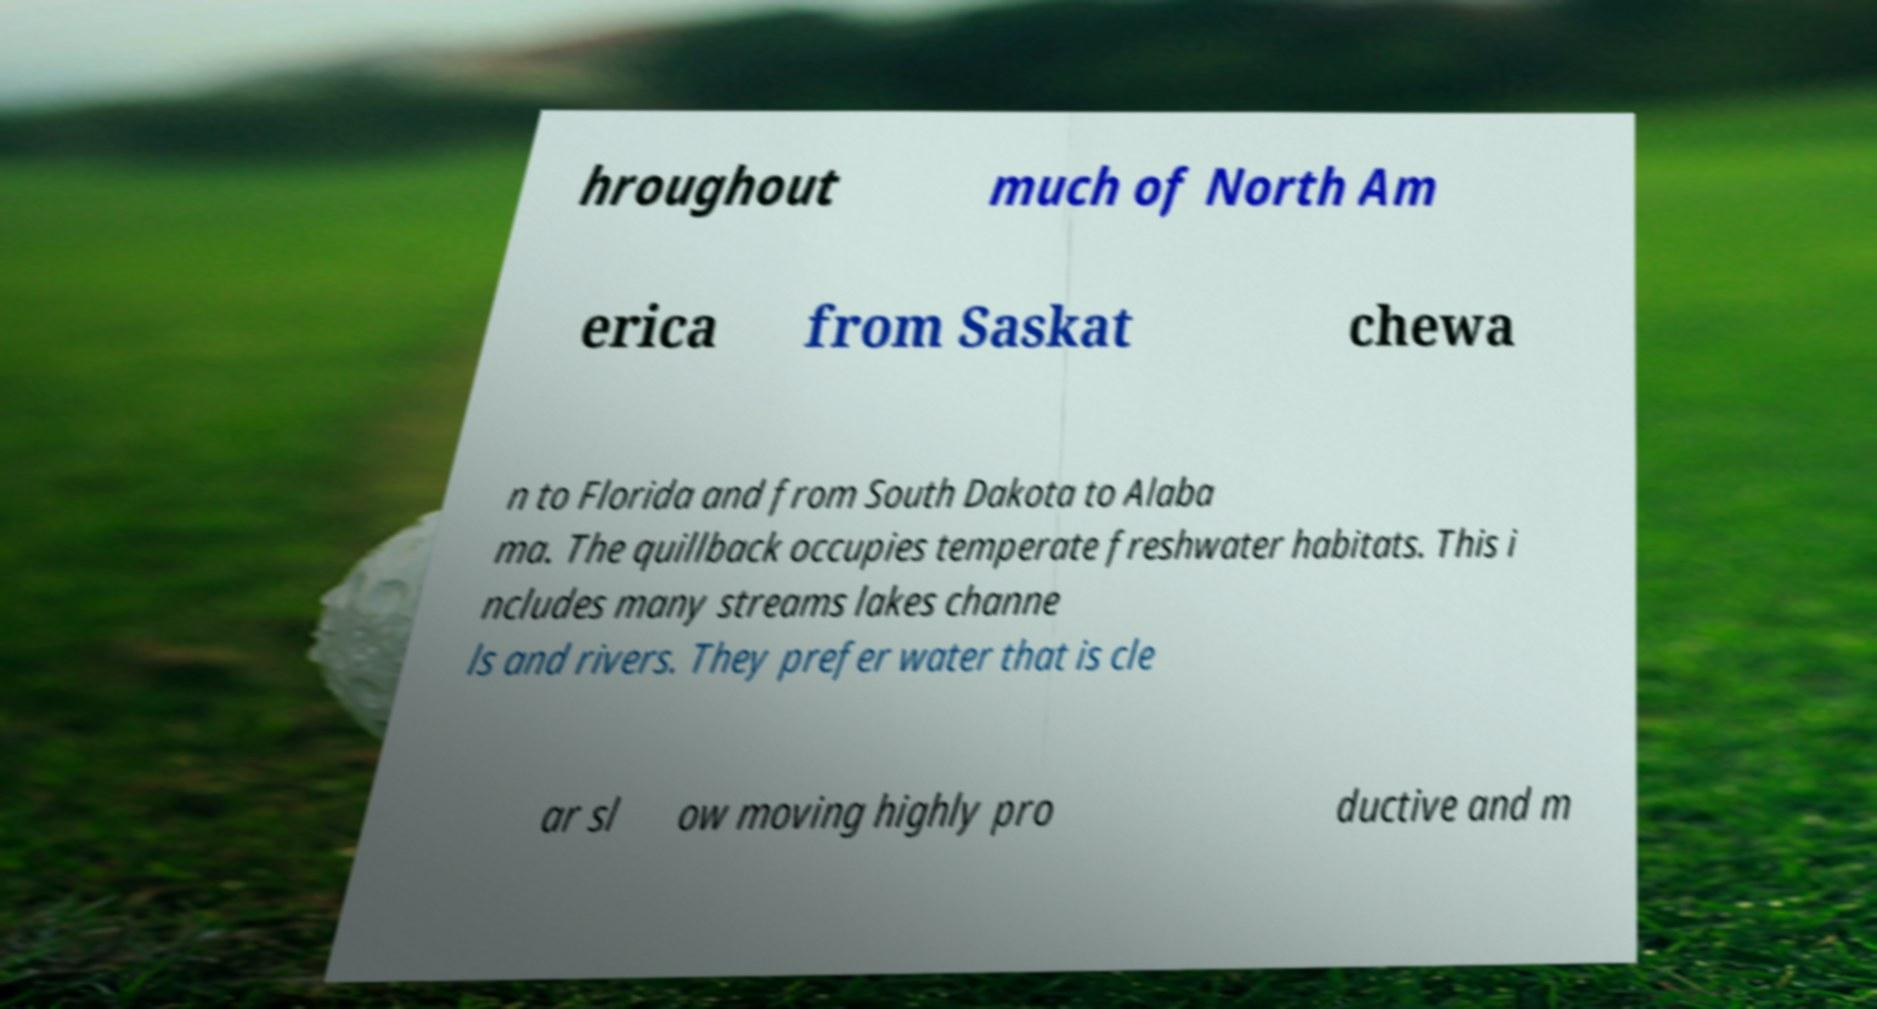Can you read and provide the text displayed in the image?This photo seems to have some interesting text. Can you extract and type it out for me? hroughout much of North Am erica from Saskat chewa n to Florida and from South Dakota to Alaba ma. The quillback occupies temperate freshwater habitats. This i ncludes many streams lakes channe ls and rivers. They prefer water that is cle ar sl ow moving highly pro ductive and m 